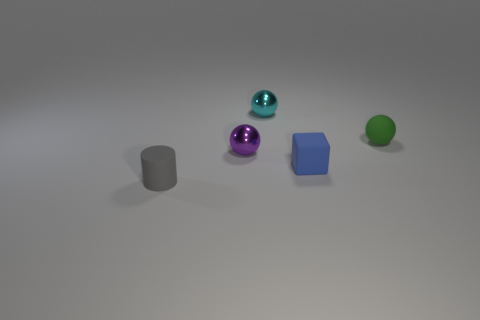The thing right of the small blue object has what shape?
Offer a terse response. Sphere. What number of objects are rubber cylinders or small blue rubber objects left of the rubber ball?
Ensure brevity in your answer.  2. Do the gray thing and the green object have the same material?
Your answer should be compact. Yes. Is the number of small balls that are on the right side of the tiny cyan sphere the same as the number of tiny blue cubes that are to the right of the small green sphere?
Your answer should be compact. No. How many gray things are right of the matte cylinder?
Give a very brief answer. 0. How many objects are small spheres or blue matte cubes?
Offer a terse response. 4. How many gray matte objects are the same size as the cyan metallic object?
Provide a succinct answer. 1. There is a small thing that is behind the tiny matte thing that is to the right of the tiny blue matte thing; what shape is it?
Provide a short and direct response. Sphere. Is the number of tiny balls less than the number of small green spheres?
Your answer should be compact. No. What color is the ball in front of the green sphere?
Provide a short and direct response. Purple. 